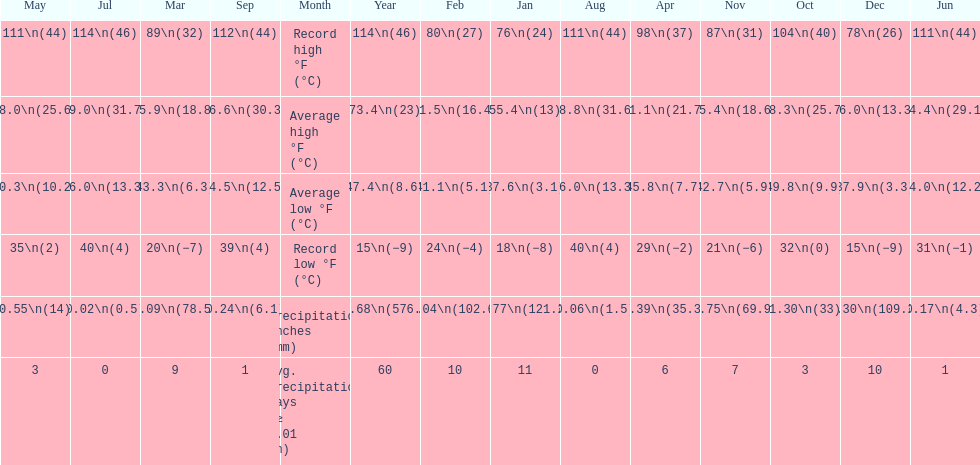How many months had a record high of 111 degrees? 3. 